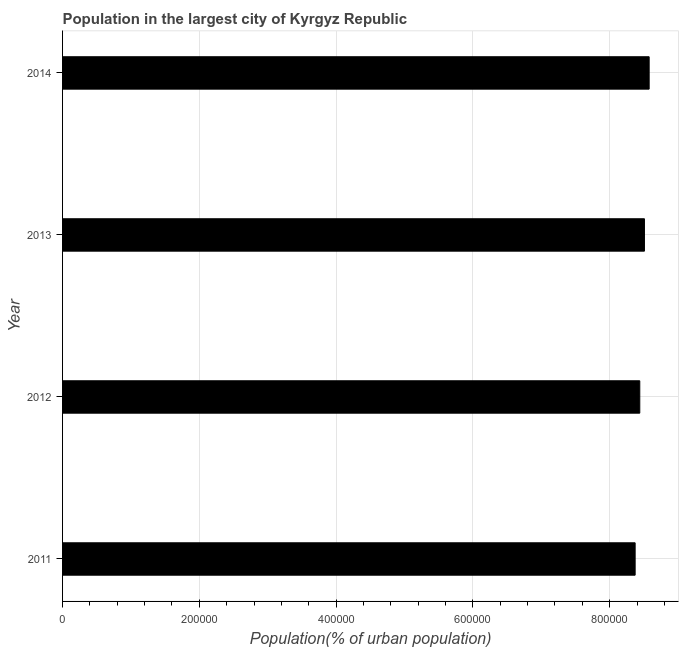Does the graph contain grids?
Provide a short and direct response. Yes. What is the title of the graph?
Provide a succinct answer. Population in the largest city of Kyrgyz Republic. What is the label or title of the X-axis?
Offer a terse response. Population(% of urban population). What is the label or title of the Y-axis?
Your response must be concise. Year. What is the population in largest city in 2013?
Ensure brevity in your answer.  8.51e+05. Across all years, what is the maximum population in largest city?
Give a very brief answer. 8.58e+05. Across all years, what is the minimum population in largest city?
Provide a succinct answer. 8.37e+05. In which year was the population in largest city maximum?
Keep it short and to the point. 2014. What is the sum of the population in largest city?
Provide a succinct answer. 3.39e+06. What is the difference between the population in largest city in 2013 and 2014?
Offer a very short reply. -6892. What is the average population in largest city per year?
Give a very brief answer. 8.47e+05. What is the median population in largest city?
Keep it short and to the point. 8.47e+05. In how many years, is the population in largest city greater than 840000 %?
Give a very brief answer. 3. What is the ratio of the population in largest city in 2012 to that in 2014?
Provide a succinct answer. 0.98. Is the difference between the population in largest city in 2012 and 2014 greater than the difference between any two years?
Your answer should be compact. No. What is the difference between the highest and the second highest population in largest city?
Provide a succinct answer. 6892. What is the difference between the highest and the lowest population in largest city?
Your response must be concise. 2.05e+04. In how many years, is the population in largest city greater than the average population in largest city taken over all years?
Ensure brevity in your answer.  2. What is the difference between two consecutive major ticks on the X-axis?
Your response must be concise. 2.00e+05. What is the Population(% of urban population) in 2011?
Offer a terse response. 8.37e+05. What is the Population(% of urban population) in 2012?
Give a very brief answer. 8.44e+05. What is the Population(% of urban population) of 2013?
Keep it short and to the point. 8.51e+05. What is the Population(% of urban population) of 2014?
Make the answer very short. 8.58e+05. What is the difference between the Population(% of urban population) in 2011 and 2012?
Keep it short and to the point. -6781. What is the difference between the Population(% of urban population) in 2011 and 2013?
Give a very brief answer. -1.36e+04. What is the difference between the Population(% of urban population) in 2011 and 2014?
Provide a succinct answer. -2.05e+04. What is the difference between the Population(% of urban population) in 2012 and 2013?
Your response must be concise. -6836. What is the difference between the Population(% of urban population) in 2012 and 2014?
Offer a very short reply. -1.37e+04. What is the difference between the Population(% of urban population) in 2013 and 2014?
Give a very brief answer. -6892. What is the ratio of the Population(% of urban population) in 2011 to that in 2013?
Keep it short and to the point. 0.98. What is the ratio of the Population(% of urban population) in 2012 to that in 2013?
Give a very brief answer. 0.99. What is the ratio of the Population(% of urban population) in 2013 to that in 2014?
Provide a short and direct response. 0.99. 